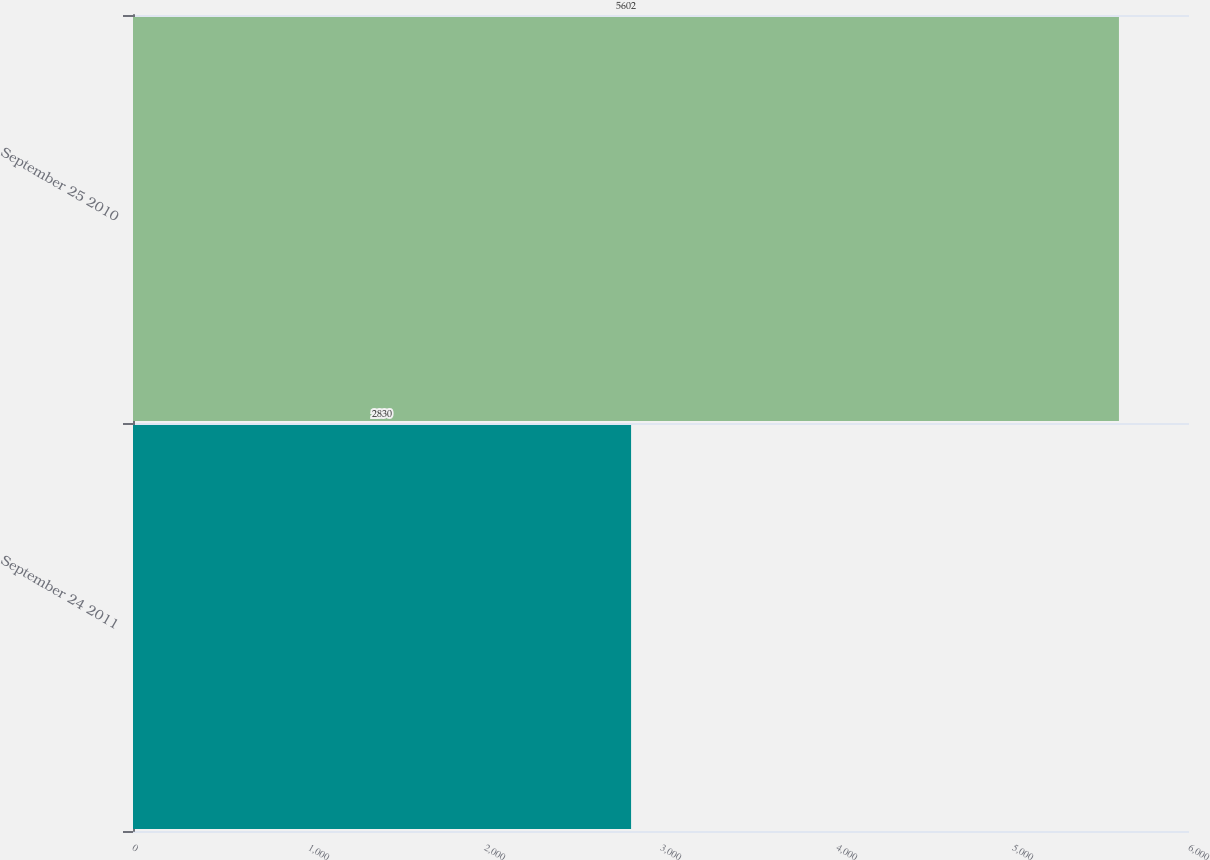<chart> <loc_0><loc_0><loc_500><loc_500><bar_chart><fcel>September 24 2011<fcel>September 25 2010<nl><fcel>2830<fcel>5602<nl></chart> 